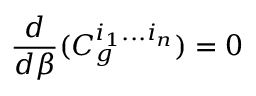Convert formula to latex. <formula><loc_0><loc_0><loc_500><loc_500>\frac { d } { d \beta } ( C _ { g } ^ { i _ { 1 } \dots i _ { n } } ) = 0</formula> 